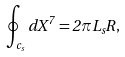Convert formula to latex. <formula><loc_0><loc_0><loc_500><loc_500>\oint _ { c _ { s } } d X ^ { 7 } = 2 \pi L _ { s } R ,</formula> 